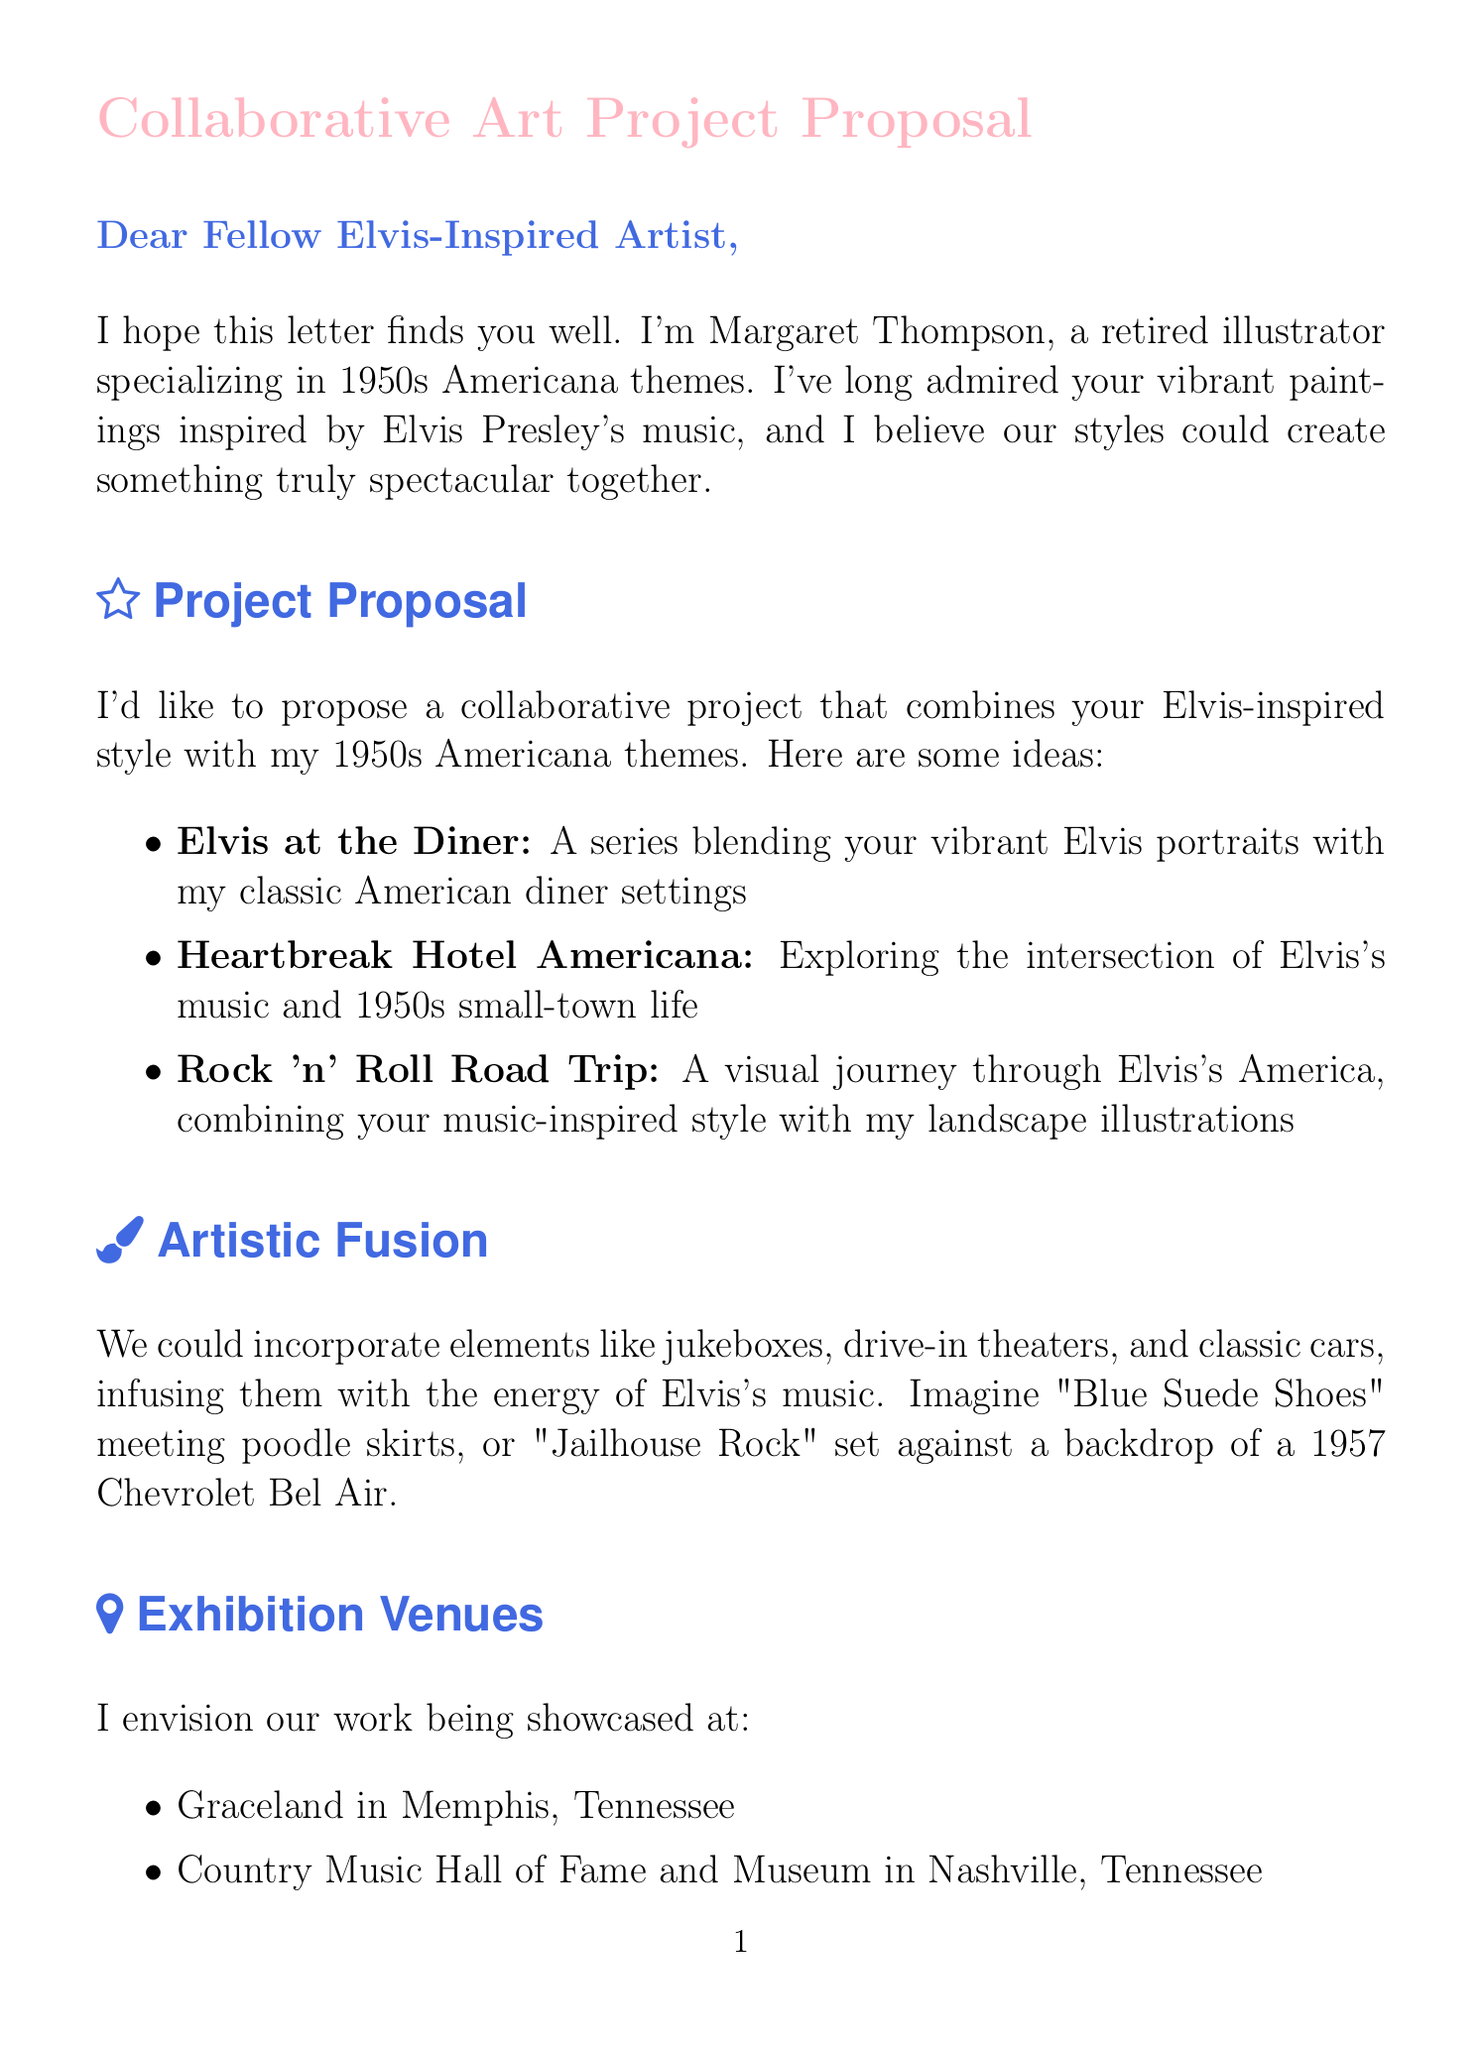What is the sender's name? The sender's name is mentioned at the end of the letter, which is Margaret Thompson.
Answer: Margaret Thompson What are the proposed exhibition venues? The document lists several venues for showcasing the collaboration, which include Graceland, Country Music Hall of Fame and Museum, and National Museum of American Illustration.
Answer: Graceland, Country Music Hall of Fame and Museum, National Museum of American Illustration What is the proposed exhibition date? The proposed exhibition date is stated in the timeline section of the letter, indicating the intended time for the exhibition.
Answer: Summer of next year How long is the initial planning phase? The document outlines the timeline for the project, specifying how long each phase will take, including the initial planning.
Answer: 2 months Which Elvis song is mentioned in the context of poodle skirts? The letter refers to a particular song in relation to the 1950s themes, highlighting a connection to fashion trends of that era.
Answer: Blue Suede Shoes What artistic techniques are proposed for the collaboration? The letter suggests combining various artistic techniques, showcasing the potential for a unique style that incorporates both artists' strengths.
Answer: Your signature vibrant acrylic painting style, My detailed pen and ink illustrations, Mixed media collages, Large-scale murals How many months are suggested for artwork creation? The document specifies a certain duration for creating the collaborative pieces, detailed in the timeline.
Answer: 6 months What type of art is Margaret Thompson specializing in? The letter introduces the sender's background, revealing their specialization and focus throughout their artistic career.
Answer: 1950s Americana themes 